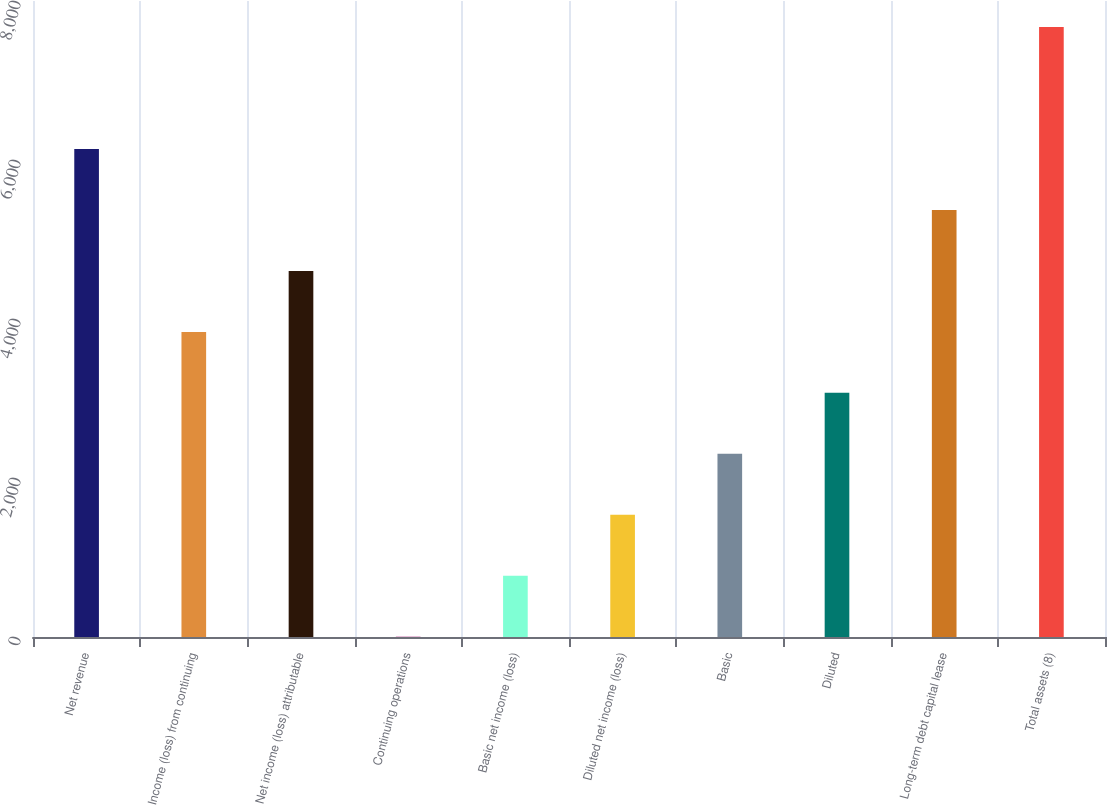Convert chart. <chart><loc_0><loc_0><loc_500><loc_500><bar_chart><fcel>Net revenue<fcel>Income (loss) from continuing<fcel>Net income (loss) attributable<fcel>Continuing operations<fcel>Basic net income (loss)<fcel>Diluted net income (loss)<fcel>Basic<fcel>Diluted<fcel>Long-term debt capital lease<fcel>Total assets (8)<nl><fcel>6138.43<fcel>3838.03<fcel>4604.83<fcel>4.03<fcel>770.83<fcel>1537.63<fcel>2304.43<fcel>3071.23<fcel>5371.63<fcel>7672<nl></chart> 